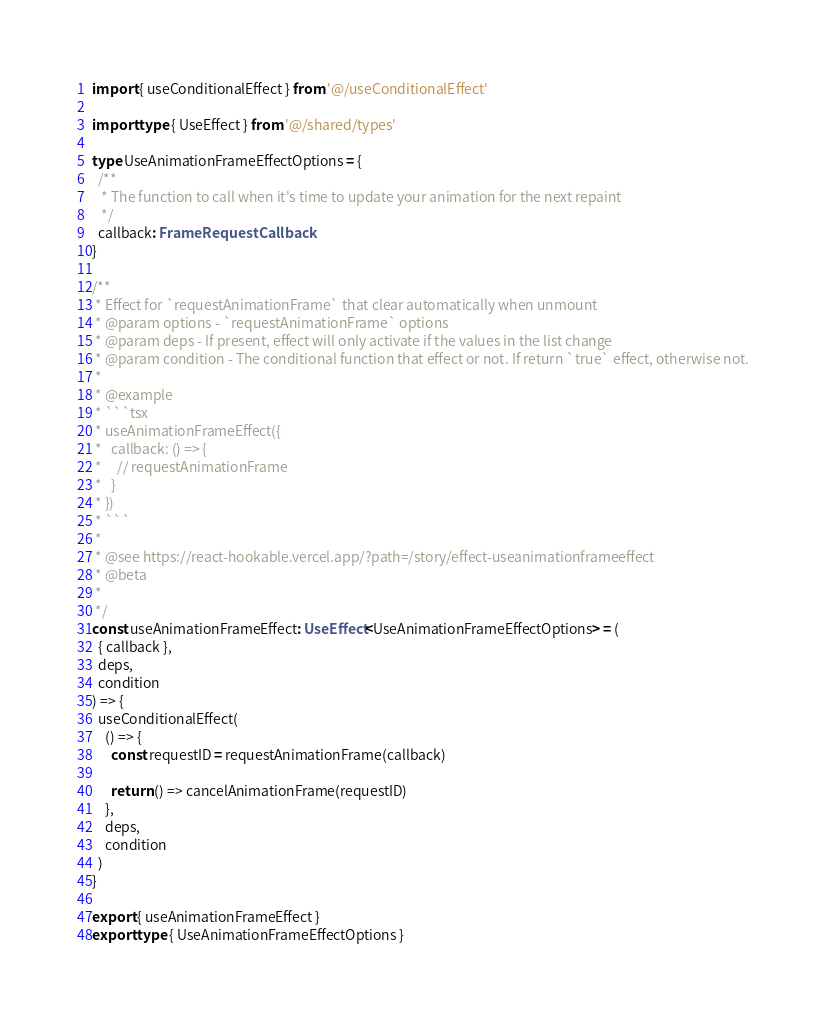Convert code to text. <code><loc_0><loc_0><loc_500><loc_500><_TypeScript_>import { useConditionalEffect } from '@/useConditionalEffect'

import type { UseEffect } from '@/shared/types'

type UseAnimationFrameEffectOptions = {
  /**
   * The function to call when it's time to update your animation for the next repaint
   */
  callback: FrameRequestCallback
}

/**
 * Effect for `requestAnimationFrame` that clear automatically when unmount
 * @param options - `requestAnimationFrame` options
 * @param deps - If present, effect will only activate if the values in the list change
 * @param condition - The conditional function that effect or not. If return `true` effect, otherwise not.
 *
 * @example
 * ```tsx
 * useAnimationFrameEffect({
 *   callback: () => {
 *     // requestAnimationFrame
 *   }
 * })
 * ```
 *
 * @see https://react-hookable.vercel.app/?path=/story/effect-useanimationframeeffect
 * @beta
 *
 */
const useAnimationFrameEffect: UseEffect<UseAnimationFrameEffectOptions> = (
  { callback },
  deps,
  condition
) => {
  useConditionalEffect(
    () => {
      const requestID = requestAnimationFrame(callback)

      return () => cancelAnimationFrame(requestID)
    },
    deps,
    condition
  )
}

export { useAnimationFrameEffect }
export type { UseAnimationFrameEffectOptions }
</code> 